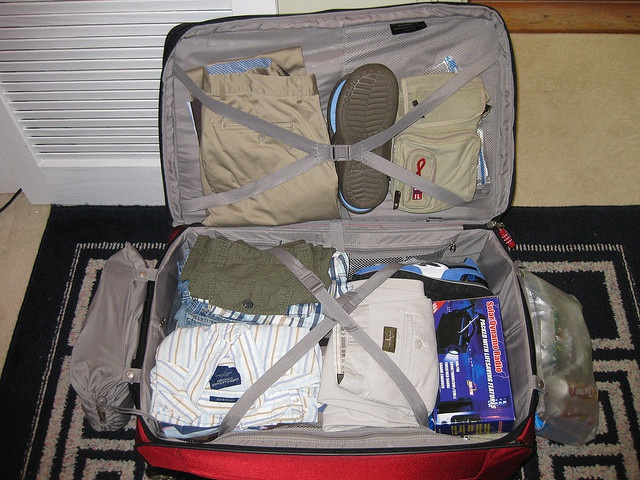Describe the objects in this image and their specific colors. I can see a suitcase in gray, darkgray, and lightgray tones in this image. 